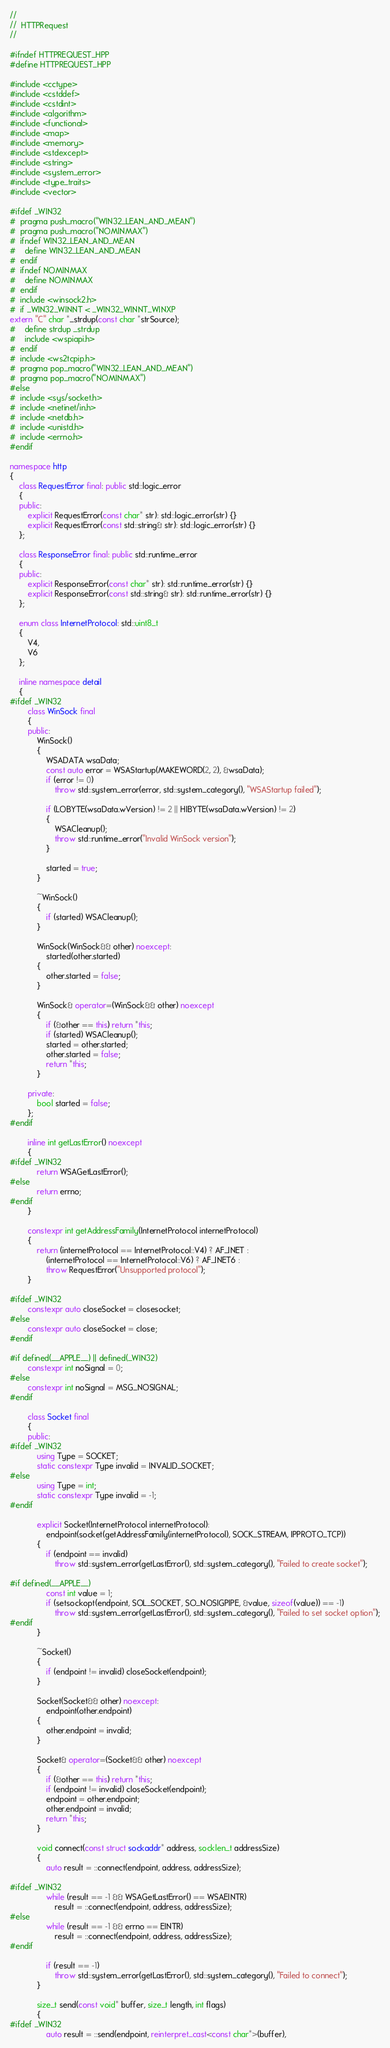Convert code to text. <code><loc_0><loc_0><loc_500><loc_500><_C++_>//
//  HTTPRequest
//

#ifndef HTTPREQUEST_HPP
#define HTTPREQUEST_HPP

#include <cctype>
#include <cstddef>
#include <cstdint>
#include <algorithm>
#include <functional>
#include <map>
#include <memory>
#include <stdexcept>
#include <string>
#include <system_error>
#include <type_traits>
#include <vector>

#ifdef _WIN32
#  pragma push_macro("WIN32_LEAN_AND_MEAN")
#  pragma push_macro("NOMINMAX")
#  ifndef WIN32_LEAN_AND_MEAN
#    define WIN32_LEAN_AND_MEAN
#  endif
#  ifndef NOMINMAX
#    define NOMINMAX
#  endif
#  include <winsock2.h>
#  if _WIN32_WINNT < _WIN32_WINNT_WINXP
extern "C" char *_strdup(const char *strSource);
#    define strdup _strdup
#    include <wspiapi.h>
#  endif
#  include <ws2tcpip.h>
#  pragma pop_macro("WIN32_LEAN_AND_MEAN")
#  pragma pop_macro("NOMINMAX")
#else
#  include <sys/socket.h>
#  include <netinet/in.h>
#  include <netdb.h>
#  include <unistd.h>
#  include <errno.h>
#endif

namespace http
{
    class RequestError final: public std::logic_error
    {
    public:
        explicit RequestError(const char* str): std::logic_error(str) {}
        explicit RequestError(const std::string& str): std::logic_error(str) {}
    };

    class ResponseError final: public std::runtime_error
    {
    public:
        explicit ResponseError(const char* str): std::runtime_error(str) {}
        explicit ResponseError(const std::string& str): std::runtime_error(str) {}
    };

    enum class InternetProtocol: std::uint8_t
    {
        V4,
        V6
    };

    inline namespace detail
    {
#ifdef _WIN32
        class WinSock final
        {
        public:
            WinSock()
            {
                WSADATA wsaData;
                const auto error = WSAStartup(MAKEWORD(2, 2), &wsaData);
                if (error != 0)
                    throw std::system_error(error, std::system_category(), "WSAStartup failed");

                if (LOBYTE(wsaData.wVersion) != 2 || HIBYTE(wsaData.wVersion) != 2)
                {
                    WSACleanup();
                    throw std::runtime_error("Invalid WinSock version");
                }

                started = true;
            }

            ~WinSock()
            {
                if (started) WSACleanup();
            }

            WinSock(WinSock&& other) noexcept:
                started(other.started)
            {
                other.started = false;
            }

            WinSock& operator=(WinSock&& other) noexcept
            {
                if (&other == this) return *this;
                if (started) WSACleanup();
                started = other.started;
                other.started = false;
                return *this;
            }

        private:
            bool started = false;
        };
#endif

        inline int getLastError() noexcept
        {
#ifdef _WIN32
            return WSAGetLastError();
#else
            return errno;
#endif
        }

        constexpr int getAddressFamily(InternetProtocol internetProtocol)
        {
            return (internetProtocol == InternetProtocol::V4) ? AF_INET :
                (internetProtocol == InternetProtocol::V6) ? AF_INET6 :
                throw RequestError("Unsupported protocol");
        }

#ifdef _WIN32
        constexpr auto closeSocket = closesocket;
#else
        constexpr auto closeSocket = close;
#endif

#if defined(__APPLE__) || defined(_WIN32)
        constexpr int noSignal = 0;
#else
        constexpr int noSignal = MSG_NOSIGNAL;
#endif

        class Socket final
        {
        public:
#ifdef _WIN32
            using Type = SOCKET;
            static constexpr Type invalid = INVALID_SOCKET;
#else
            using Type = int;
            static constexpr Type invalid = -1;
#endif

            explicit Socket(InternetProtocol internetProtocol):
                endpoint(socket(getAddressFamily(internetProtocol), SOCK_STREAM, IPPROTO_TCP))
            {
                if (endpoint == invalid)
                    throw std::system_error(getLastError(), std::system_category(), "Failed to create socket");

#if defined(__APPLE__)
                const int value = 1;
                if (setsockopt(endpoint, SOL_SOCKET, SO_NOSIGPIPE, &value, sizeof(value)) == -1)
                    throw std::system_error(getLastError(), std::system_category(), "Failed to set socket option");
#endif
            }

            ~Socket()
            {
                if (endpoint != invalid) closeSocket(endpoint);
            }

            Socket(Socket&& other) noexcept:
                endpoint(other.endpoint)
            {
                other.endpoint = invalid;
            }

            Socket& operator=(Socket&& other) noexcept
            {
                if (&other == this) return *this;
                if (endpoint != invalid) closeSocket(endpoint);
                endpoint = other.endpoint;
                other.endpoint = invalid;
                return *this;
            }

            void connect(const struct sockaddr* address, socklen_t addressSize)
            {
                auto result = ::connect(endpoint, address, addressSize);

#ifdef _WIN32
                while (result == -1 && WSAGetLastError() == WSAEINTR)
                    result = ::connect(endpoint, address, addressSize);
#else
                while (result == -1 && errno == EINTR)
                    result = ::connect(endpoint, address, addressSize);
#endif

                if (result == -1)
                    throw std::system_error(getLastError(), std::system_category(), "Failed to connect");
            }

            size_t send(const void* buffer, size_t length, int flags)
            {
#ifdef _WIN32
                auto result = ::send(endpoint, reinterpret_cast<const char*>(buffer),</code> 